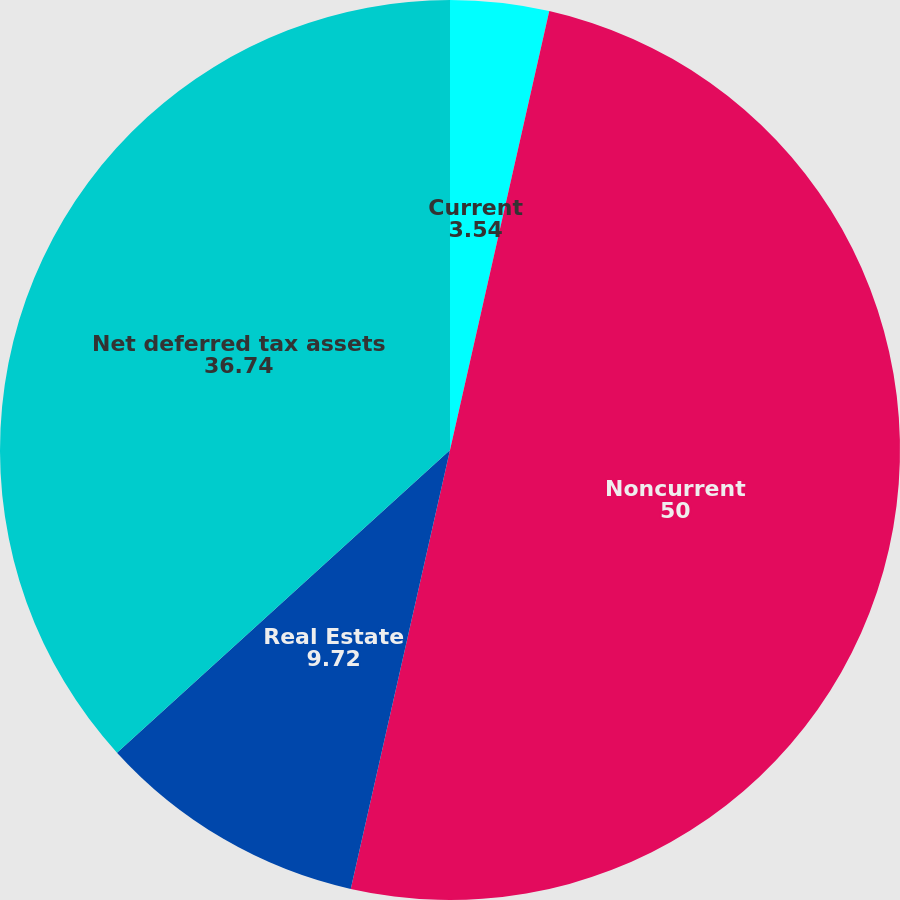<chart> <loc_0><loc_0><loc_500><loc_500><pie_chart><fcel>Current<fcel>Noncurrent<fcel>Real Estate<fcel>Net deferred tax assets<nl><fcel>3.54%<fcel>50.0%<fcel>9.72%<fcel>36.74%<nl></chart> 